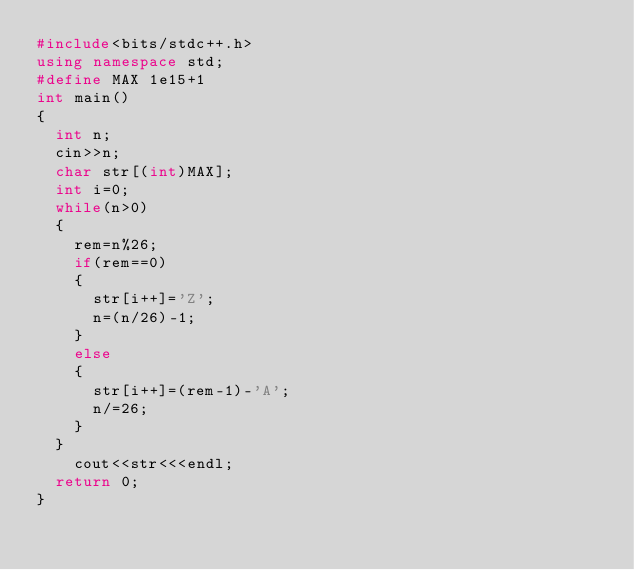Convert code to text. <code><loc_0><loc_0><loc_500><loc_500><_C++_>#include<bits/stdc++.h>
using namespace std;
#define MAX 1e15+1
int main()
{
  int n;
  cin>>n;
  char str[(int)MAX];
  int i=0;
  while(n>0)
  {
    rem=n%26;
    if(rem==0)
    {
      str[i++]='Z';
      n=(n/26)-1;
    }
    else
    {
      str[i++]=(rem-1)-'A';
      n/=26;
    }
  }
    cout<<str<<<endl;
  return 0;
}
    </code> 